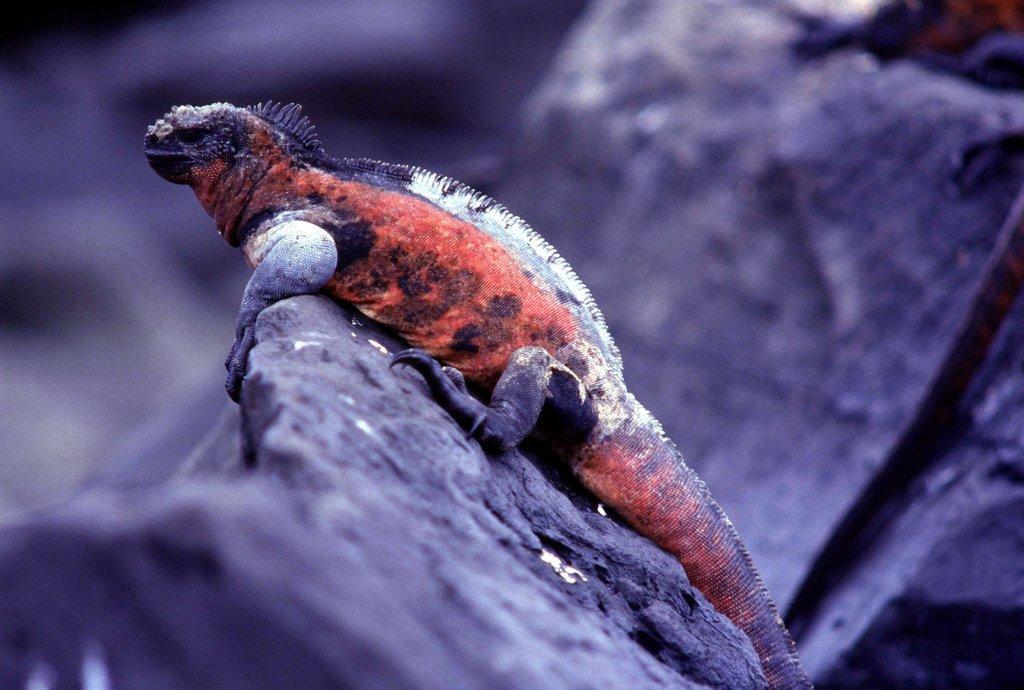Could you give a brief overview of what you see in this image? In this image we can see the chameleon on rocks, which is red, black, and white in color. 